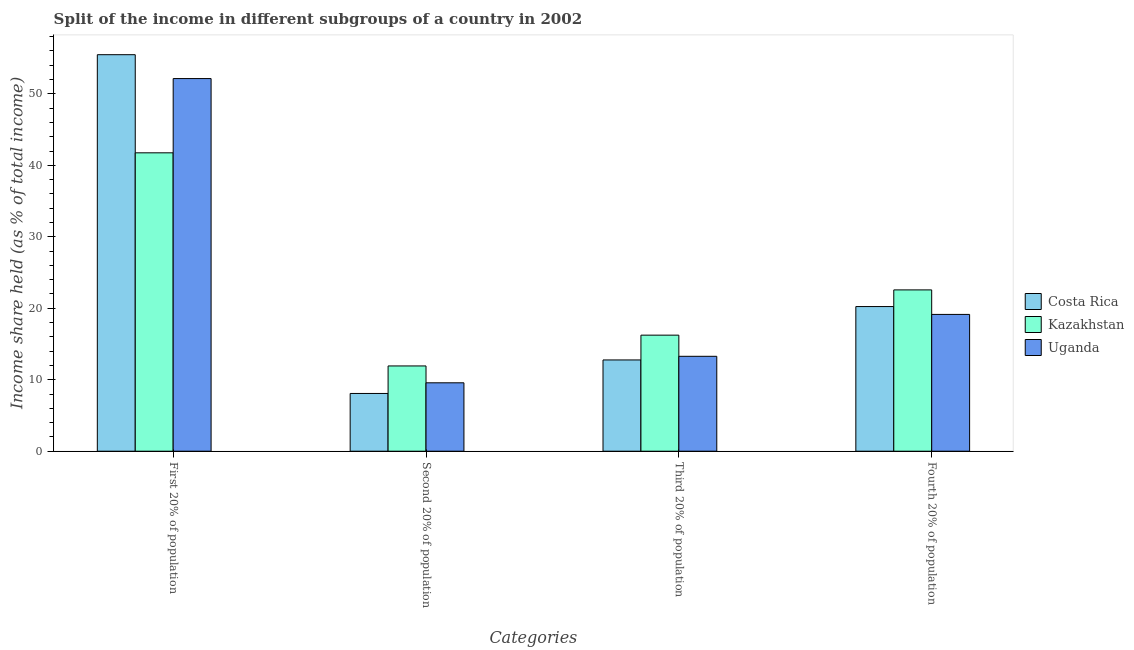How many different coloured bars are there?
Offer a terse response. 3. How many groups of bars are there?
Offer a terse response. 4. Are the number of bars per tick equal to the number of legend labels?
Provide a short and direct response. Yes. How many bars are there on the 4th tick from the right?
Make the answer very short. 3. What is the label of the 3rd group of bars from the left?
Provide a succinct answer. Third 20% of population. What is the share of the income held by fourth 20% of the population in Kazakhstan?
Your response must be concise. 22.57. Across all countries, what is the maximum share of the income held by fourth 20% of the population?
Offer a terse response. 22.57. Across all countries, what is the minimum share of the income held by fourth 20% of the population?
Offer a terse response. 19.14. In which country was the share of the income held by third 20% of the population maximum?
Give a very brief answer. Kazakhstan. In which country was the share of the income held by third 20% of the population minimum?
Offer a very short reply. Costa Rica. What is the total share of the income held by second 20% of the population in the graph?
Give a very brief answer. 29.58. What is the difference between the share of the income held by second 20% of the population in Kazakhstan and that in Uganda?
Offer a terse response. 2.36. What is the difference between the share of the income held by first 20% of the population in Uganda and the share of the income held by fourth 20% of the population in Kazakhstan?
Provide a succinct answer. 29.57. What is the average share of the income held by fourth 20% of the population per country?
Give a very brief answer. 20.65. What is the difference between the share of the income held by first 20% of the population and share of the income held by second 20% of the population in Kazakhstan?
Make the answer very short. 29.82. What is the ratio of the share of the income held by second 20% of the population in Uganda to that in Kazakhstan?
Keep it short and to the point. 0.8. What is the difference between the highest and the second highest share of the income held by fourth 20% of the population?
Provide a succinct answer. 2.33. What is the difference between the highest and the lowest share of the income held by second 20% of the population?
Offer a very short reply. 3.85. In how many countries, is the share of the income held by fourth 20% of the population greater than the average share of the income held by fourth 20% of the population taken over all countries?
Your answer should be compact. 1. Is it the case that in every country, the sum of the share of the income held by fourth 20% of the population and share of the income held by second 20% of the population is greater than the sum of share of the income held by first 20% of the population and share of the income held by third 20% of the population?
Your answer should be compact. No. What does the 1st bar from the left in First 20% of population represents?
Ensure brevity in your answer.  Costa Rica. What does the 1st bar from the right in Third 20% of population represents?
Provide a short and direct response. Uganda. Are all the bars in the graph horizontal?
Your answer should be very brief. No. How many countries are there in the graph?
Your answer should be very brief. 3. Does the graph contain grids?
Offer a very short reply. No. How many legend labels are there?
Your answer should be compact. 3. How are the legend labels stacked?
Your response must be concise. Vertical. What is the title of the graph?
Provide a succinct answer. Split of the income in different subgroups of a country in 2002. Does "France" appear as one of the legend labels in the graph?
Your answer should be compact. No. What is the label or title of the X-axis?
Give a very brief answer. Categories. What is the label or title of the Y-axis?
Offer a terse response. Income share held (as % of total income). What is the Income share held (as % of total income) in Costa Rica in First 20% of population?
Offer a terse response. 55.48. What is the Income share held (as % of total income) in Kazakhstan in First 20% of population?
Keep it short and to the point. 41.75. What is the Income share held (as % of total income) of Uganda in First 20% of population?
Make the answer very short. 52.14. What is the Income share held (as % of total income) in Costa Rica in Second 20% of population?
Provide a succinct answer. 8.08. What is the Income share held (as % of total income) in Kazakhstan in Second 20% of population?
Keep it short and to the point. 11.93. What is the Income share held (as % of total income) of Uganda in Second 20% of population?
Your response must be concise. 9.57. What is the Income share held (as % of total income) of Costa Rica in Third 20% of population?
Make the answer very short. 12.77. What is the Income share held (as % of total income) of Kazakhstan in Third 20% of population?
Provide a succinct answer. 16.24. What is the Income share held (as % of total income) in Uganda in Third 20% of population?
Keep it short and to the point. 13.28. What is the Income share held (as % of total income) of Costa Rica in Fourth 20% of population?
Provide a succinct answer. 20.24. What is the Income share held (as % of total income) of Kazakhstan in Fourth 20% of population?
Keep it short and to the point. 22.57. What is the Income share held (as % of total income) in Uganda in Fourth 20% of population?
Keep it short and to the point. 19.14. Across all Categories, what is the maximum Income share held (as % of total income) of Costa Rica?
Provide a short and direct response. 55.48. Across all Categories, what is the maximum Income share held (as % of total income) in Kazakhstan?
Your answer should be very brief. 41.75. Across all Categories, what is the maximum Income share held (as % of total income) of Uganda?
Ensure brevity in your answer.  52.14. Across all Categories, what is the minimum Income share held (as % of total income) of Costa Rica?
Your answer should be very brief. 8.08. Across all Categories, what is the minimum Income share held (as % of total income) in Kazakhstan?
Provide a succinct answer. 11.93. Across all Categories, what is the minimum Income share held (as % of total income) in Uganda?
Provide a short and direct response. 9.57. What is the total Income share held (as % of total income) of Costa Rica in the graph?
Offer a terse response. 96.57. What is the total Income share held (as % of total income) in Kazakhstan in the graph?
Your response must be concise. 92.49. What is the total Income share held (as % of total income) in Uganda in the graph?
Provide a short and direct response. 94.13. What is the difference between the Income share held (as % of total income) in Costa Rica in First 20% of population and that in Second 20% of population?
Make the answer very short. 47.4. What is the difference between the Income share held (as % of total income) in Kazakhstan in First 20% of population and that in Second 20% of population?
Your response must be concise. 29.82. What is the difference between the Income share held (as % of total income) in Uganda in First 20% of population and that in Second 20% of population?
Your answer should be very brief. 42.57. What is the difference between the Income share held (as % of total income) in Costa Rica in First 20% of population and that in Third 20% of population?
Make the answer very short. 42.71. What is the difference between the Income share held (as % of total income) of Kazakhstan in First 20% of population and that in Third 20% of population?
Your response must be concise. 25.51. What is the difference between the Income share held (as % of total income) in Uganda in First 20% of population and that in Third 20% of population?
Your response must be concise. 38.86. What is the difference between the Income share held (as % of total income) of Costa Rica in First 20% of population and that in Fourth 20% of population?
Keep it short and to the point. 35.24. What is the difference between the Income share held (as % of total income) in Kazakhstan in First 20% of population and that in Fourth 20% of population?
Ensure brevity in your answer.  19.18. What is the difference between the Income share held (as % of total income) in Uganda in First 20% of population and that in Fourth 20% of population?
Your answer should be compact. 33. What is the difference between the Income share held (as % of total income) in Costa Rica in Second 20% of population and that in Third 20% of population?
Offer a very short reply. -4.69. What is the difference between the Income share held (as % of total income) in Kazakhstan in Second 20% of population and that in Third 20% of population?
Your answer should be compact. -4.31. What is the difference between the Income share held (as % of total income) of Uganda in Second 20% of population and that in Third 20% of population?
Ensure brevity in your answer.  -3.71. What is the difference between the Income share held (as % of total income) of Costa Rica in Second 20% of population and that in Fourth 20% of population?
Offer a terse response. -12.16. What is the difference between the Income share held (as % of total income) in Kazakhstan in Second 20% of population and that in Fourth 20% of population?
Your response must be concise. -10.64. What is the difference between the Income share held (as % of total income) of Uganda in Second 20% of population and that in Fourth 20% of population?
Provide a short and direct response. -9.57. What is the difference between the Income share held (as % of total income) in Costa Rica in Third 20% of population and that in Fourth 20% of population?
Keep it short and to the point. -7.47. What is the difference between the Income share held (as % of total income) of Kazakhstan in Third 20% of population and that in Fourth 20% of population?
Keep it short and to the point. -6.33. What is the difference between the Income share held (as % of total income) in Uganda in Third 20% of population and that in Fourth 20% of population?
Your answer should be compact. -5.86. What is the difference between the Income share held (as % of total income) of Costa Rica in First 20% of population and the Income share held (as % of total income) of Kazakhstan in Second 20% of population?
Your answer should be compact. 43.55. What is the difference between the Income share held (as % of total income) of Costa Rica in First 20% of population and the Income share held (as % of total income) of Uganda in Second 20% of population?
Offer a very short reply. 45.91. What is the difference between the Income share held (as % of total income) in Kazakhstan in First 20% of population and the Income share held (as % of total income) in Uganda in Second 20% of population?
Keep it short and to the point. 32.18. What is the difference between the Income share held (as % of total income) in Costa Rica in First 20% of population and the Income share held (as % of total income) in Kazakhstan in Third 20% of population?
Your answer should be very brief. 39.24. What is the difference between the Income share held (as % of total income) of Costa Rica in First 20% of population and the Income share held (as % of total income) of Uganda in Third 20% of population?
Offer a terse response. 42.2. What is the difference between the Income share held (as % of total income) in Kazakhstan in First 20% of population and the Income share held (as % of total income) in Uganda in Third 20% of population?
Provide a short and direct response. 28.47. What is the difference between the Income share held (as % of total income) in Costa Rica in First 20% of population and the Income share held (as % of total income) in Kazakhstan in Fourth 20% of population?
Your answer should be compact. 32.91. What is the difference between the Income share held (as % of total income) in Costa Rica in First 20% of population and the Income share held (as % of total income) in Uganda in Fourth 20% of population?
Provide a short and direct response. 36.34. What is the difference between the Income share held (as % of total income) in Kazakhstan in First 20% of population and the Income share held (as % of total income) in Uganda in Fourth 20% of population?
Your response must be concise. 22.61. What is the difference between the Income share held (as % of total income) in Costa Rica in Second 20% of population and the Income share held (as % of total income) in Kazakhstan in Third 20% of population?
Offer a very short reply. -8.16. What is the difference between the Income share held (as % of total income) in Costa Rica in Second 20% of population and the Income share held (as % of total income) in Uganda in Third 20% of population?
Provide a short and direct response. -5.2. What is the difference between the Income share held (as % of total income) of Kazakhstan in Second 20% of population and the Income share held (as % of total income) of Uganda in Third 20% of population?
Keep it short and to the point. -1.35. What is the difference between the Income share held (as % of total income) in Costa Rica in Second 20% of population and the Income share held (as % of total income) in Kazakhstan in Fourth 20% of population?
Provide a short and direct response. -14.49. What is the difference between the Income share held (as % of total income) of Costa Rica in Second 20% of population and the Income share held (as % of total income) of Uganda in Fourth 20% of population?
Ensure brevity in your answer.  -11.06. What is the difference between the Income share held (as % of total income) in Kazakhstan in Second 20% of population and the Income share held (as % of total income) in Uganda in Fourth 20% of population?
Give a very brief answer. -7.21. What is the difference between the Income share held (as % of total income) in Costa Rica in Third 20% of population and the Income share held (as % of total income) in Uganda in Fourth 20% of population?
Ensure brevity in your answer.  -6.37. What is the average Income share held (as % of total income) in Costa Rica per Categories?
Make the answer very short. 24.14. What is the average Income share held (as % of total income) of Kazakhstan per Categories?
Your answer should be compact. 23.12. What is the average Income share held (as % of total income) in Uganda per Categories?
Your response must be concise. 23.53. What is the difference between the Income share held (as % of total income) in Costa Rica and Income share held (as % of total income) in Kazakhstan in First 20% of population?
Make the answer very short. 13.73. What is the difference between the Income share held (as % of total income) of Costa Rica and Income share held (as % of total income) of Uganda in First 20% of population?
Offer a terse response. 3.34. What is the difference between the Income share held (as % of total income) in Kazakhstan and Income share held (as % of total income) in Uganda in First 20% of population?
Provide a succinct answer. -10.39. What is the difference between the Income share held (as % of total income) in Costa Rica and Income share held (as % of total income) in Kazakhstan in Second 20% of population?
Offer a terse response. -3.85. What is the difference between the Income share held (as % of total income) in Costa Rica and Income share held (as % of total income) in Uganda in Second 20% of population?
Provide a succinct answer. -1.49. What is the difference between the Income share held (as % of total income) of Kazakhstan and Income share held (as % of total income) of Uganda in Second 20% of population?
Make the answer very short. 2.36. What is the difference between the Income share held (as % of total income) in Costa Rica and Income share held (as % of total income) in Kazakhstan in Third 20% of population?
Your answer should be very brief. -3.47. What is the difference between the Income share held (as % of total income) in Costa Rica and Income share held (as % of total income) in Uganda in Third 20% of population?
Provide a short and direct response. -0.51. What is the difference between the Income share held (as % of total income) in Kazakhstan and Income share held (as % of total income) in Uganda in Third 20% of population?
Keep it short and to the point. 2.96. What is the difference between the Income share held (as % of total income) in Costa Rica and Income share held (as % of total income) in Kazakhstan in Fourth 20% of population?
Give a very brief answer. -2.33. What is the difference between the Income share held (as % of total income) of Costa Rica and Income share held (as % of total income) of Uganda in Fourth 20% of population?
Your response must be concise. 1.1. What is the difference between the Income share held (as % of total income) of Kazakhstan and Income share held (as % of total income) of Uganda in Fourth 20% of population?
Ensure brevity in your answer.  3.43. What is the ratio of the Income share held (as % of total income) of Costa Rica in First 20% of population to that in Second 20% of population?
Provide a short and direct response. 6.87. What is the ratio of the Income share held (as % of total income) in Kazakhstan in First 20% of population to that in Second 20% of population?
Give a very brief answer. 3.5. What is the ratio of the Income share held (as % of total income) in Uganda in First 20% of population to that in Second 20% of population?
Your answer should be very brief. 5.45. What is the ratio of the Income share held (as % of total income) in Costa Rica in First 20% of population to that in Third 20% of population?
Offer a very short reply. 4.34. What is the ratio of the Income share held (as % of total income) in Kazakhstan in First 20% of population to that in Third 20% of population?
Keep it short and to the point. 2.57. What is the ratio of the Income share held (as % of total income) in Uganda in First 20% of population to that in Third 20% of population?
Keep it short and to the point. 3.93. What is the ratio of the Income share held (as % of total income) of Costa Rica in First 20% of population to that in Fourth 20% of population?
Ensure brevity in your answer.  2.74. What is the ratio of the Income share held (as % of total income) in Kazakhstan in First 20% of population to that in Fourth 20% of population?
Provide a short and direct response. 1.85. What is the ratio of the Income share held (as % of total income) of Uganda in First 20% of population to that in Fourth 20% of population?
Provide a succinct answer. 2.72. What is the ratio of the Income share held (as % of total income) in Costa Rica in Second 20% of population to that in Third 20% of population?
Make the answer very short. 0.63. What is the ratio of the Income share held (as % of total income) of Kazakhstan in Second 20% of population to that in Third 20% of population?
Give a very brief answer. 0.73. What is the ratio of the Income share held (as % of total income) in Uganda in Second 20% of population to that in Third 20% of population?
Ensure brevity in your answer.  0.72. What is the ratio of the Income share held (as % of total income) of Costa Rica in Second 20% of population to that in Fourth 20% of population?
Ensure brevity in your answer.  0.4. What is the ratio of the Income share held (as % of total income) in Kazakhstan in Second 20% of population to that in Fourth 20% of population?
Your answer should be very brief. 0.53. What is the ratio of the Income share held (as % of total income) in Uganda in Second 20% of population to that in Fourth 20% of population?
Make the answer very short. 0.5. What is the ratio of the Income share held (as % of total income) of Costa Rica in Third 20% of population to that in Fourth 20% of population?
Provide a short and direct response. 0.63. What is the ratio of the Income share held (as % of total income) of Kazakhstan in Third 20% of population to that in Fourth 20% of population?
Provide a short and direct response. 0.72. What is the ratio of the Income share held (as % of total income) in Uganda in Third 20% of population to that in Fourth 20% of population?
Give a very brief answer. 0.69. What is the difference between the highest and the second highest Income share held (as % of total income) in Costa Rica?
Provide a succinct answer. 35.24. What is the difference between the highest and the second highest Income share held (as % of total income) in Kazakhstan?
Offer a very short reply. 19.18. What is the difference between the highest and the lowest Income share held (as % of total income) of Costa Rica?
Your answer should be very brief. 47.4. What is the difference between the highest and the lowest Income share held (as % of total income) of Kazakhstan?
Give a very brief answer. 29.82. What is the difference between the highest and the lowest Income share held (as % of total income) of Uganda?
Offer a very short reply. 42.57. 